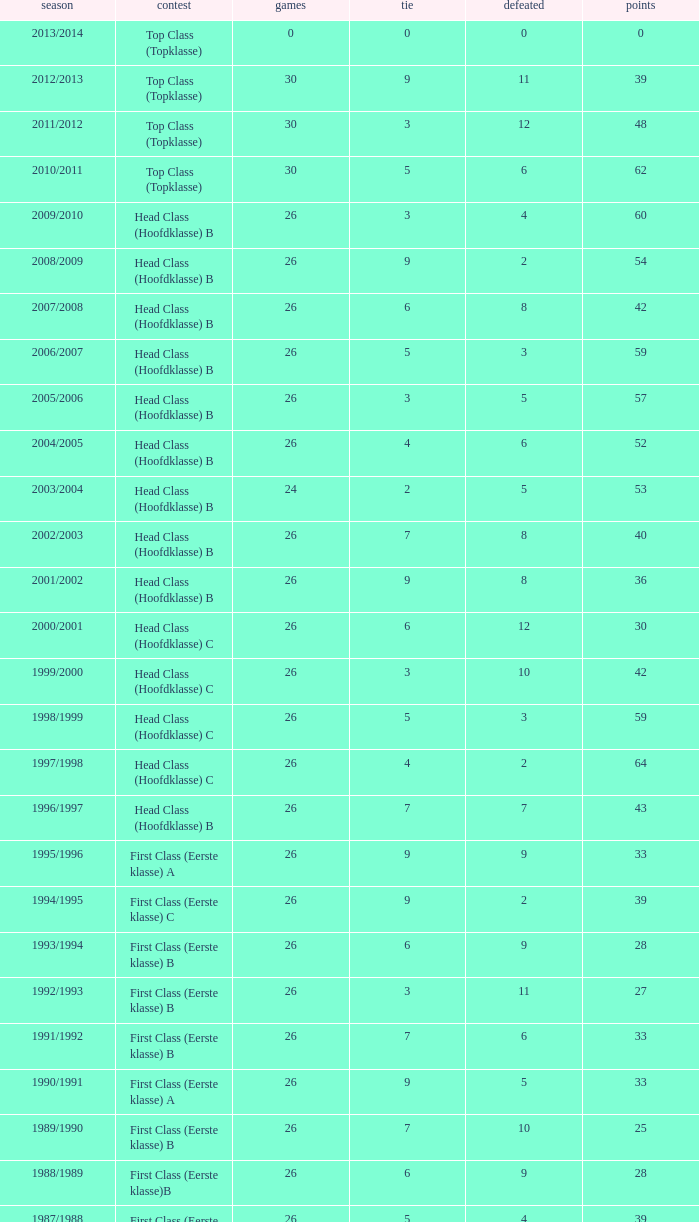What is the total number of matches with a loss less than 5 in the 2008/2009 season and has a draw larger than 9? 0.0. 